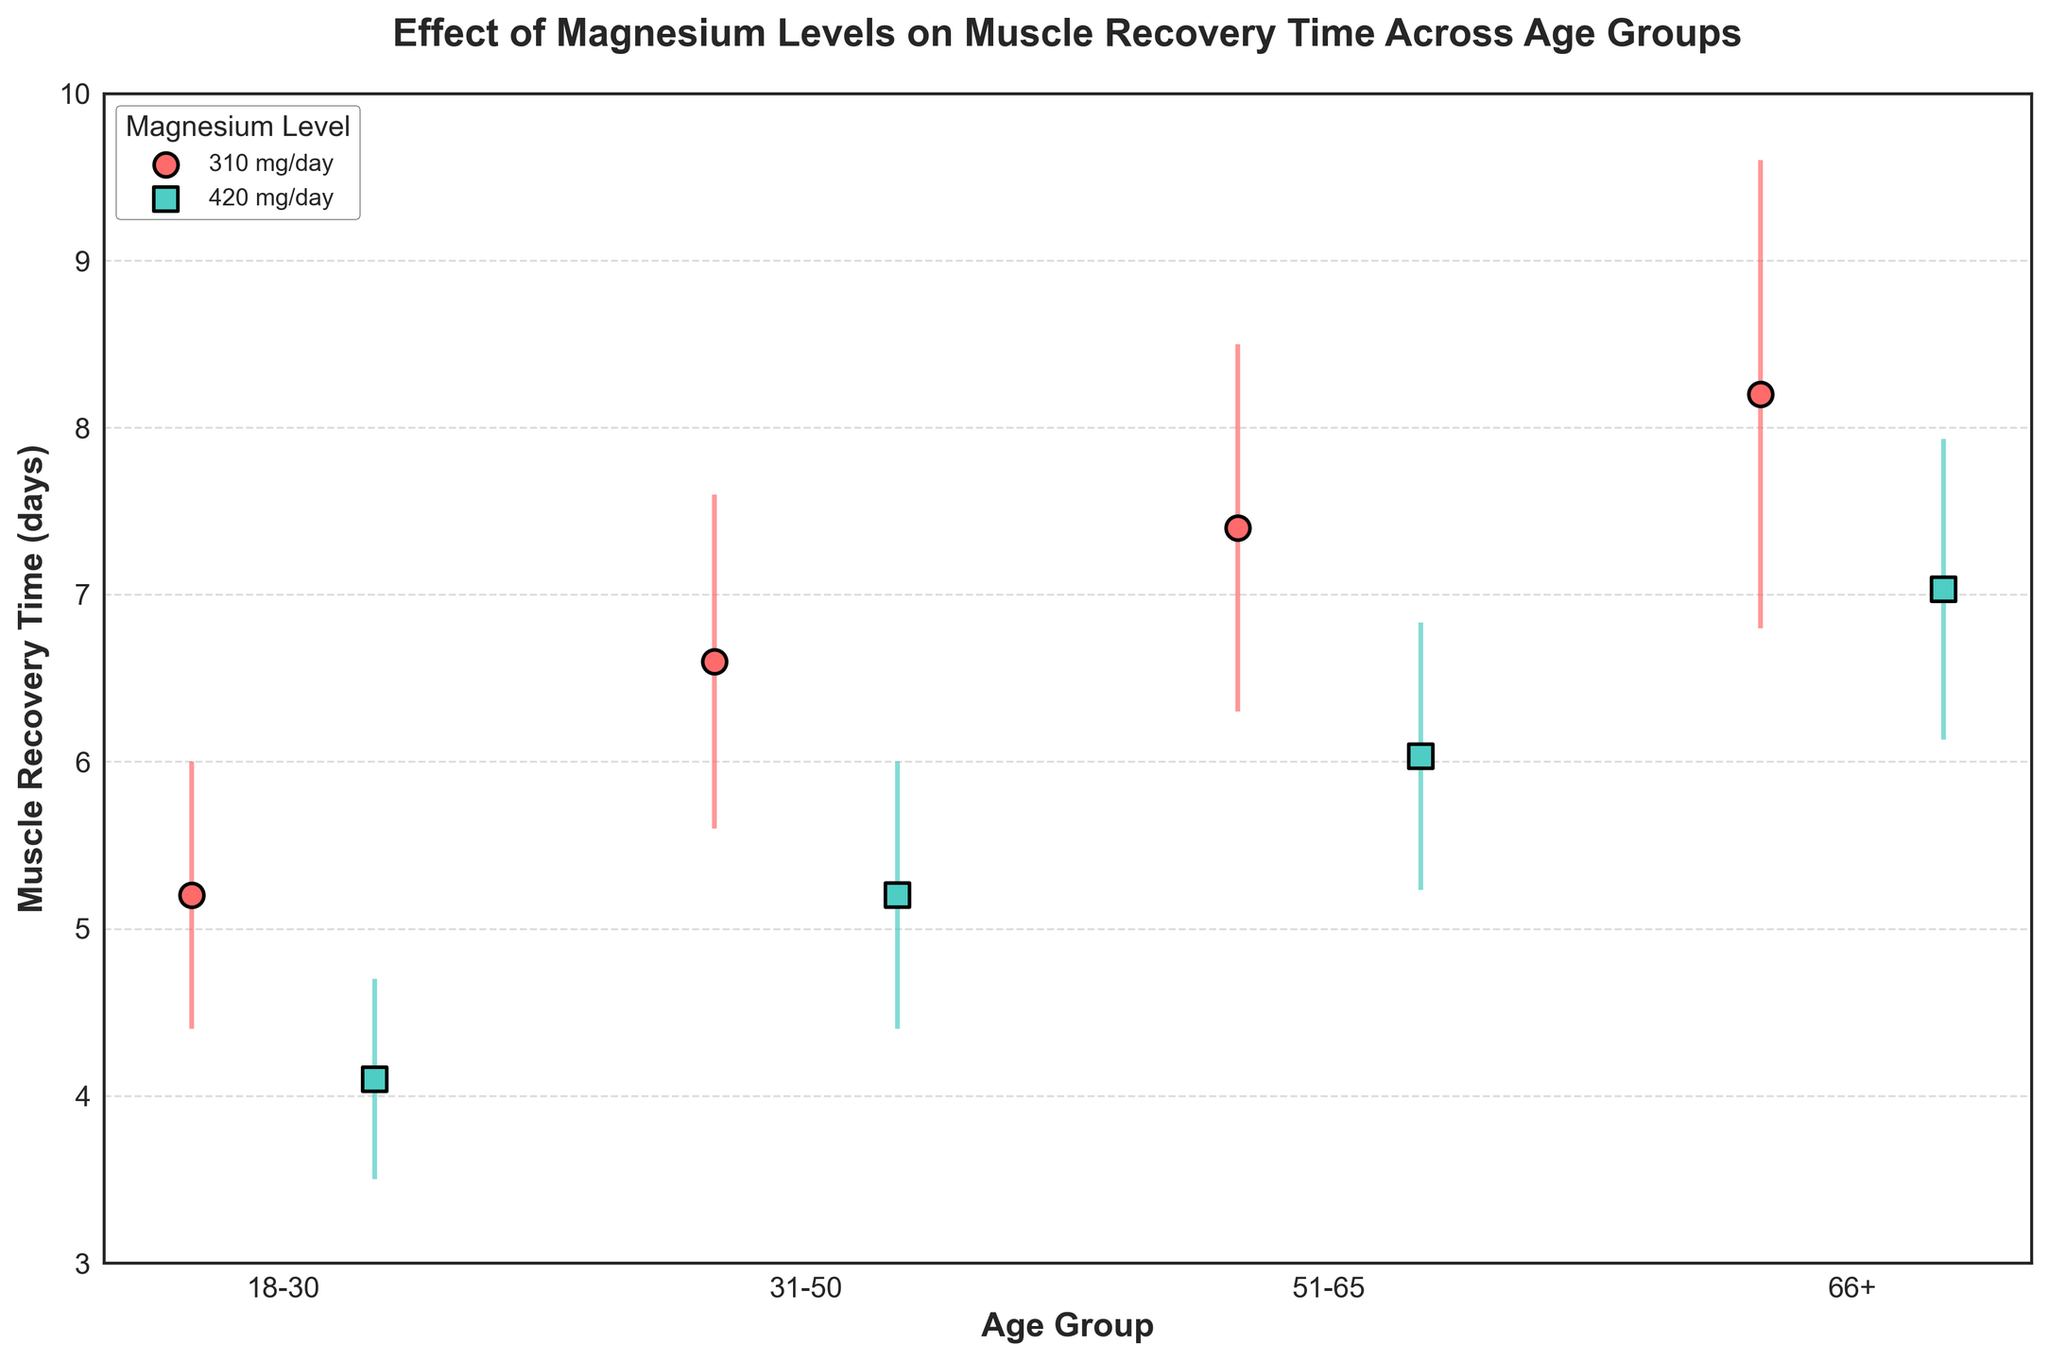What is the title of the figure? The title is displayed at the top of the figure and summarizes its content.
Answer: Effect of Magnesium Levels on Muscle Recovery Time Across Age Groups What are the age groups represented on the x-axis? The age groups are labeled on the x-axis and provide information on the different demographic groups studied.
Answer: 18-30, 31-50, 51-65, 66+ Which magnesium level has a lower average muscle recovery time for the 31-50 age group? Compare the average muscle recovery times for the 310 mg/day and 420 mg/day magnesium levels for the 31-50 age group on the y-axis.
Answer: 420 mg/day What is the range of muscle recovery times displayed on the y-axis? The range is shown along the y-axis and indicates the span of muscle recovery times covered in the figure.
Answer: 3 to 10 days What is the difference in average muscle recovery time for the 66+ age group between the two magnesium levels? Find the average muscle recovery times for the 66+ age group for both magnesium levels, then subtract the smaller from the larger.
Answer: 1.2 days What pattern can you observe in the muscle recovery times as the magnesium level increases from 310 mg/day to 420 mg/day? Look at the trend of the dots and error bars for both magnesium levels across all age groups.
Answer: Decrease in muscle recovery times Which age group has the highest muscle recovery time at the 310 mg/day magnesium level? Compare the muscle recovery times for the 310 mg/day magnesium level across all age groups and find the highest one.
Answer: 66+ Are the error bars larger for older age groups or younger age groups? Compare the lengths of the error bars among the different age groups to determine which group has larger variability.
Answer: Older age groups Is there any age group where the muscle recovery times for 310 mg/day and 420 mg/day magnesium levels overlap within the error bars? Check if the error bars for both magnesium levels overlap for any age group.
Answer: Yes, 66+ What is the average muscle recovery time for the 51-65 age group at the 420 mg/day magnesium level, considering the data points shown? Find the average of the muscle recovery times for the 51-65 age group at the 420 mg/day level from the data points in the figure.
Answer: 6 days 